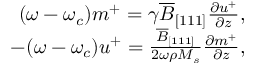<formula> <loc_0><loc_0><loc_500><loc_500>\begin{array} { r } { ( \omega - \omega _ { c } ) m ^ { + } = \gamma \overline { B } _ { [ 1 1 1 ] } \frac { \partial u ^ { + } } { \partial z } , } \\ { - ( \omega - \omega _ { c } ) u ^ { + } = \frac { \overline { B } _ { [ 1 1 1 ] } } { 2 \omega \rho M _ { s } } \frac { \partial m ^ { + } } { \partial z } , } \end{array}</formula> 